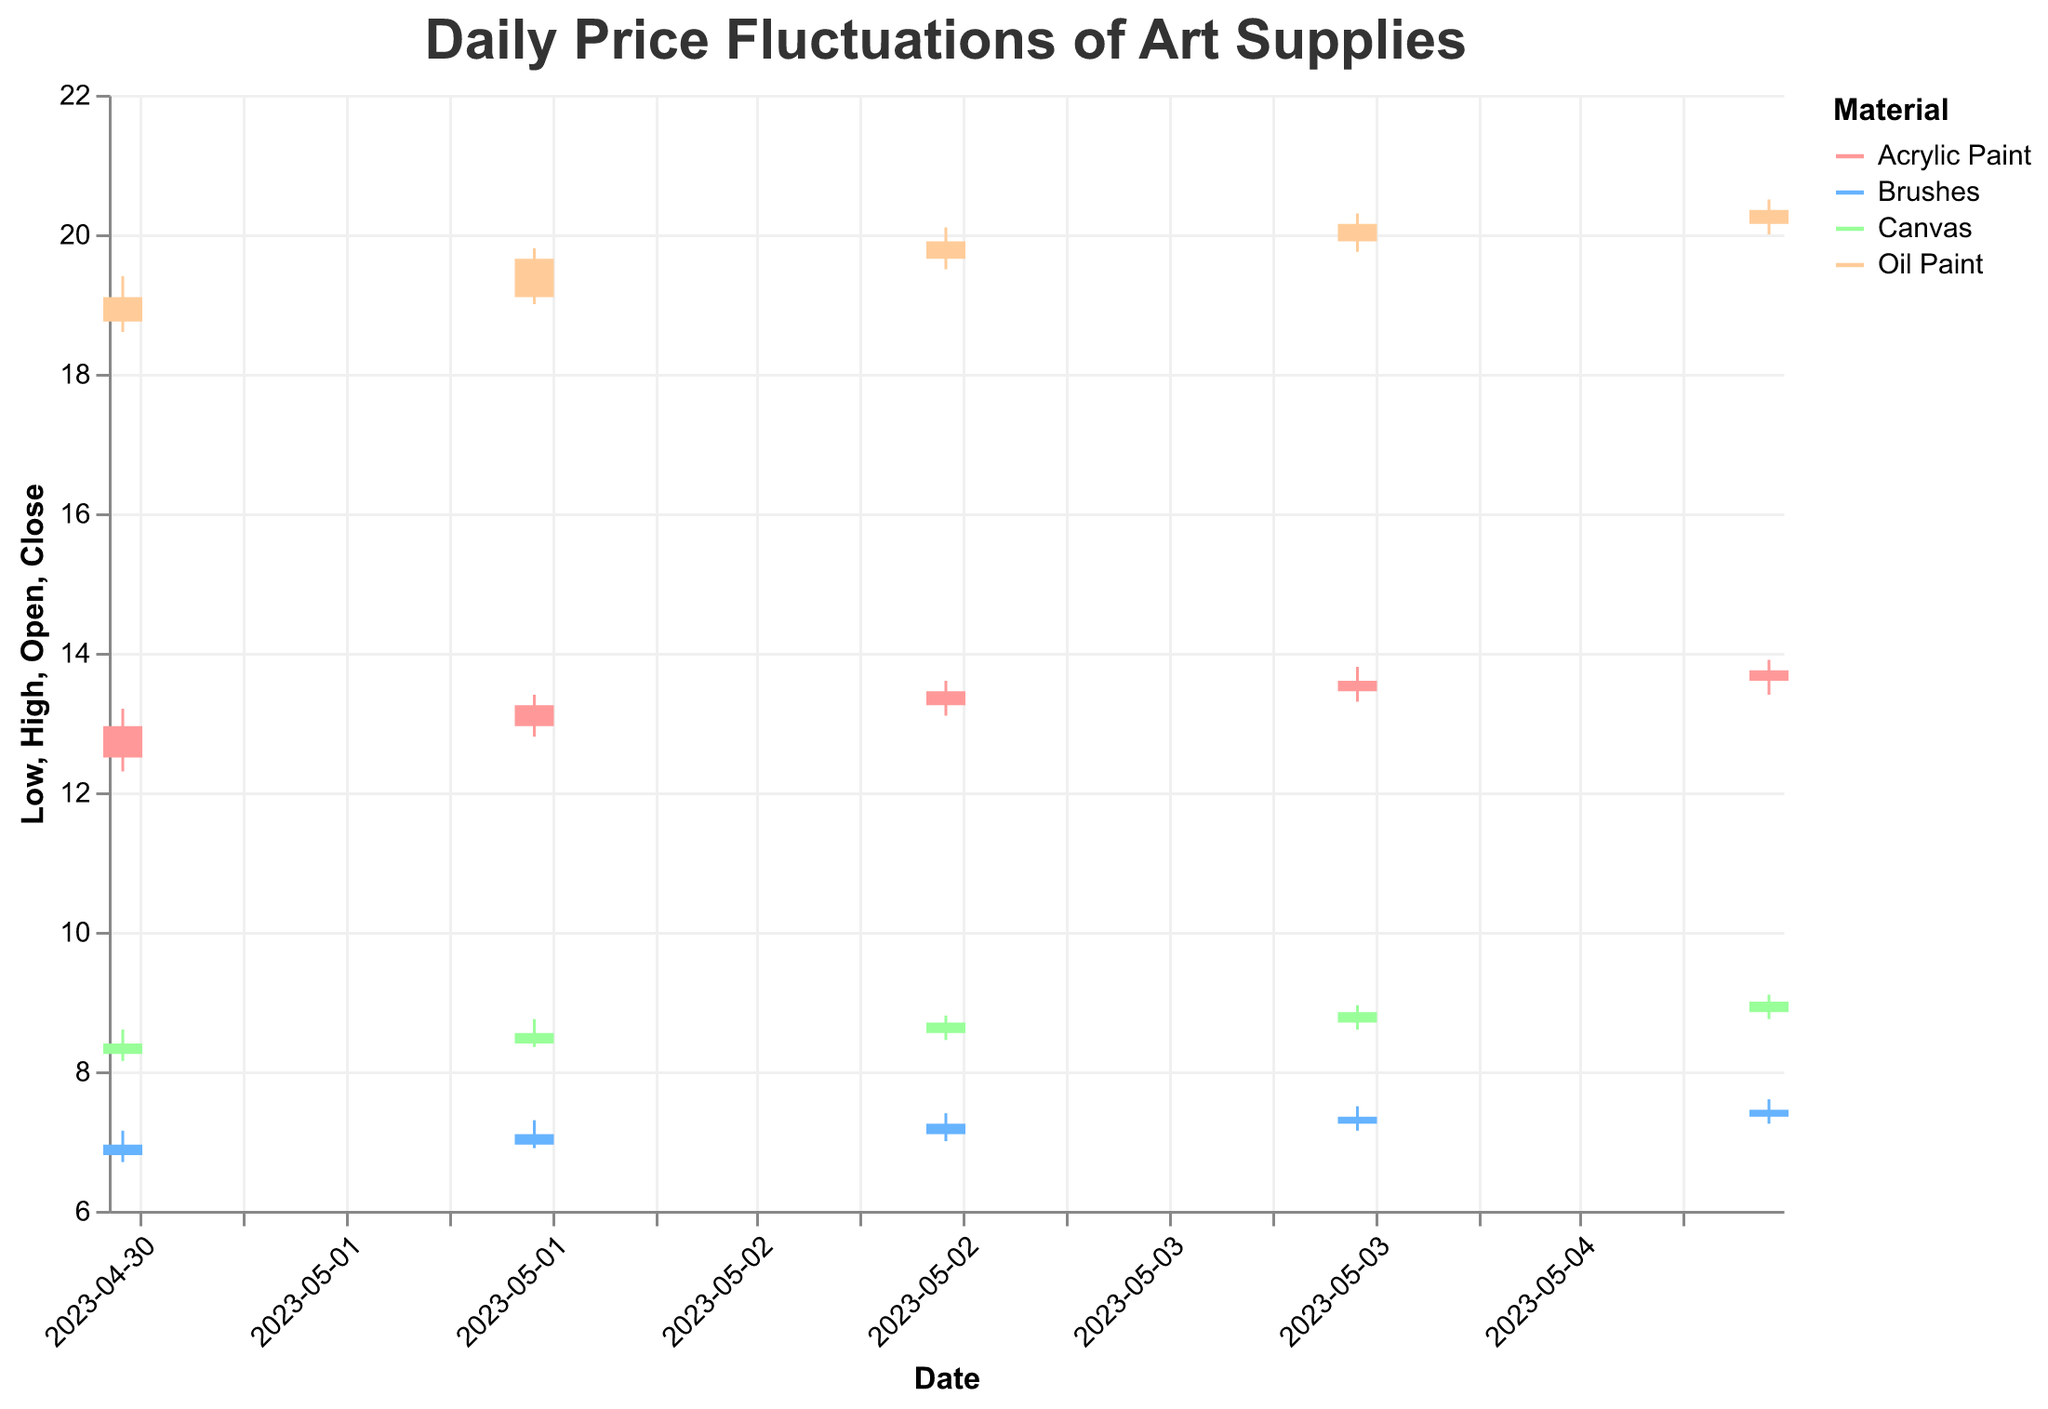What is the highest price recorded for Oil Paint on May 2nd, 2023? The highest price for Oil Paint on May 2nd, 2023 is indicated by the top value in the vertical rule for that date, which is 19.80.
Answer: 19.80 What is the closing price of Acrylic Paint on May 3rd, 2023? The closing price for Acrylic Paint on May 3rd, 2023 is shown by the endpoint of the bar for that material and date, which stops at 13.45.
Answer: 13.45 Which material had the largest price range on May 1st, 2023? To determine the largest price range, calculate the difference between the high and low prices for each material on May 1st, 2023: Acrylic Paint (13.20 - 12.30 = 0.90), Oil Paint (19.40 - 18.60 = 0.80), Canvas (8.60 - 8.15 = 0.45), Brushes (7.15 - 6.70 = 0.45). The largest range is for Acrylic Paint with a range of 0.90.
Answer: Acrylic Paint How did the closing price of Brushes change between May 4th and May 5th, 2023? On May 4th, the closing price for Brushes is 7.35. On May 5th, it is 7.45. The change is calculated as 7.45 - 7.35, an increase.
Answer: Increased by 0.10 Which material had the highest opening price on May 5th, 2023? On May 5th, the opening prices are: Acrylic Paint (13.60), Oil Paint (20.15), Canvas (8.85), Brushes (7.35). The highest opening price is for Oil Paint at 20.15.
Answer: Oil Paint What is the average closing price for Canvas over the five days? To find the average, sum the closing prices for Canvas over the given days and then divide by the number of days: (8.40 + 8.55 + 8.70 + 8.85 + 9.00) / 5 = 43.50 / 5 = 8.70.
Answer: 8.70 Which material had the smallest fluctuation on May 3rd, 2023? Calculate the difference between the high and low prices for each material on May 3rd: Acrylic Paint (13.60 - 13.10 = 0.50), Oil Paint (20.10 - 19.50 = 0.60), Canvas (8.80 - 8.45 = 0.35), Brushes (7.40 - 7.00 = 0.40). The smallest fluctuation is for Canvas with a range of 0.35.
Answer: Canvas Did the closing price for Oil Paint increase or decrease between May 1st and May 5th, 2023? On May 1st, the closing price for Oil Paint is 19.10, and on May 5th, it is 20.35. Since 20.35 is greater than 19.10, the closing price increased.
Answer: Increased What is the highest high price recorded for Brushes in the data? Examine the 'High' prices for Brushes across all dates: (7.15, 7.30, 7.40, 7.50, 7.60). The highest high price is 7.60, which occurs on May 5th.
Answer: 7.60 